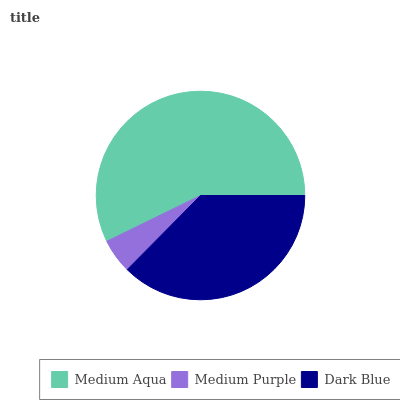Is Medium Purple the minimum?
Answer yes or no. Yes. Is Medium Aqua the maximum?
Answer yes or no. Yes. Is Dark Blue the minimum?
Answer yes or no. No. Is Dark Blue the maximum?
Answer yes or no. No. Is Dark Blue greater than Medium Purple?
Answer yes or no. Yes. Is Medium Purple less than Dark Blue?
Answer yes or no. Yes. Is Medium Purple greater than Dark Blue?
Answer yes or no. No. Is Dark Blue less than Medium Purple?
Answer yes or no. No. Is Dark Blue the high median?
Answer yes or no. Yes. Is Dark Blue the low median?
Answer yes or no. Yes. Is Medium Purple the high median?
Answer yes or no. No. Is Medium Aqua the low median?
Answer yes or no. No. 